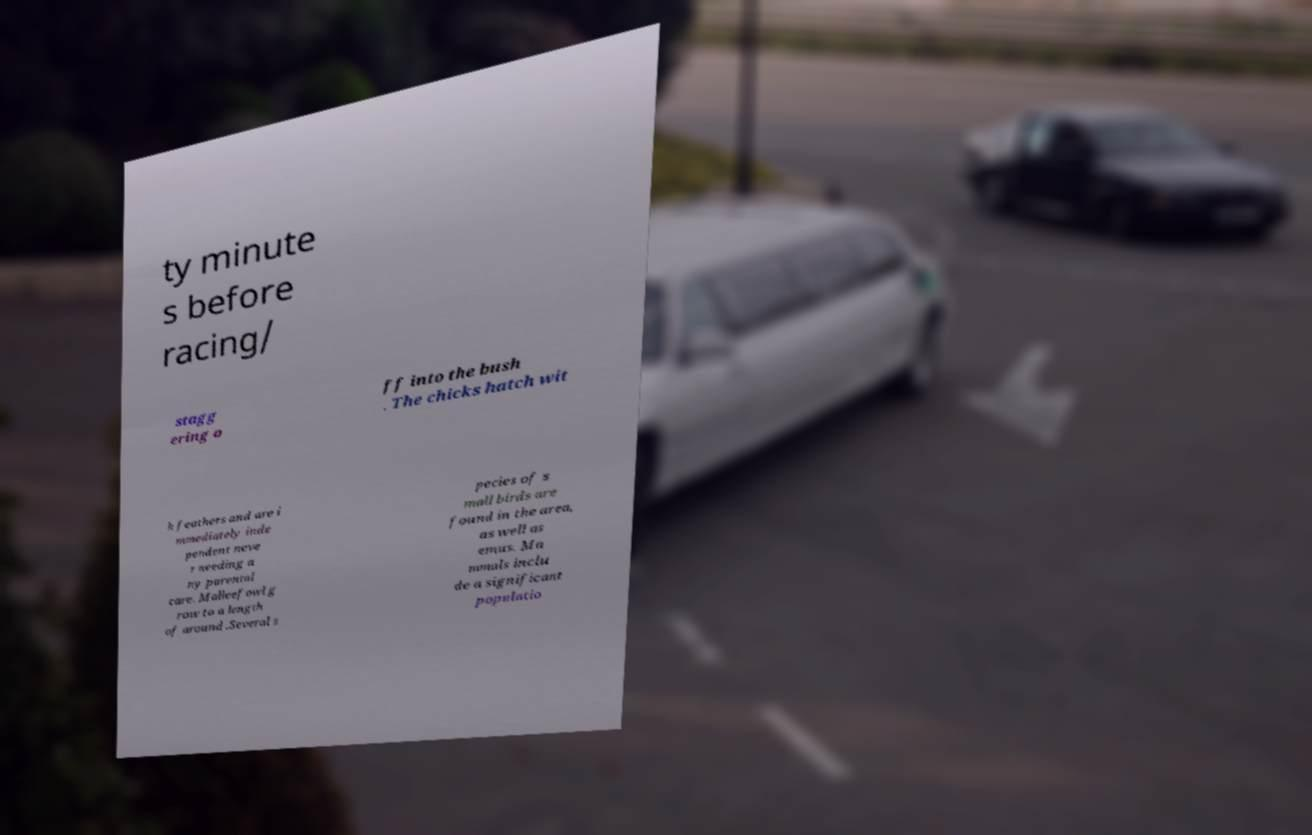Could you extract and type out the text from this image? ty minute s before racing/ stagg ering o ff into the bush . The chicks hatch wit h feathers and are i mmediately inde pendent neve r needing a ny parental care. Malleefowl g row to a length of around .Several s pecies of s mall birds are found in the area, as well as emus. Ma mmals inclu de a significant populatio 